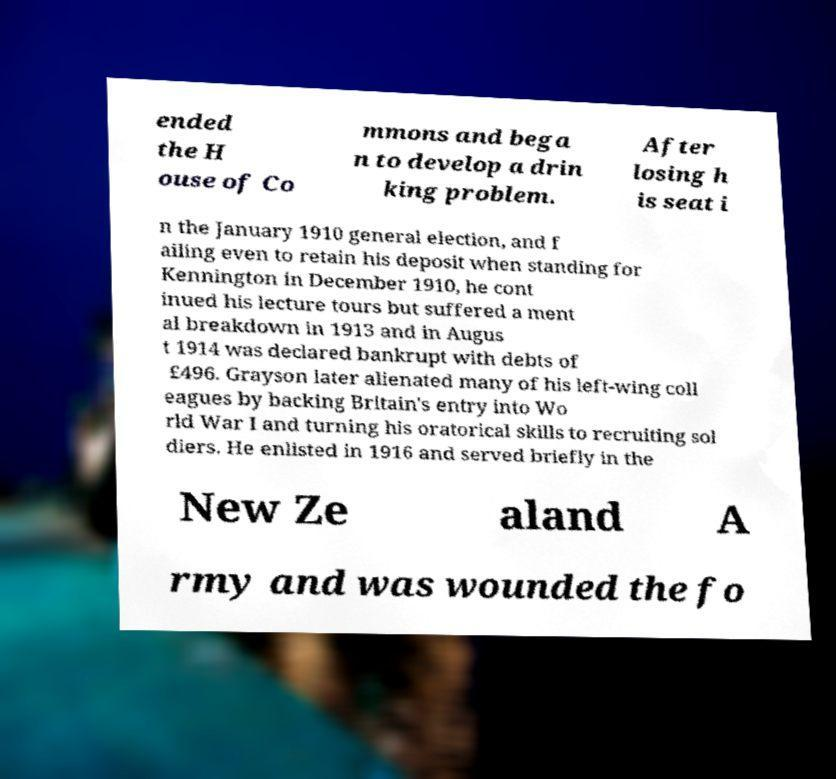What messages or text are displayed in this image? I need them in a readable, typed format. ended the H ouse of Co mmons and bega n to develop a drin king problem. After losing h is seat i n the January 1910 general election, and f ailing even to retain his deposit when standing for Kennington in December 1910, he cont inued his lecture tours but suffered a ment al breakdown in 1913 and in Augus t 1914 was declared bankrupt with debts of £496. Grayson later alienated many of his left-wing coll eagues by backing Britain's entry into Wo rld War I and turning his oratorical skills to recruiting sol diers. He enlisted in 1916 and served briefly in the New Ze aland A rmy and was wounded the fo 